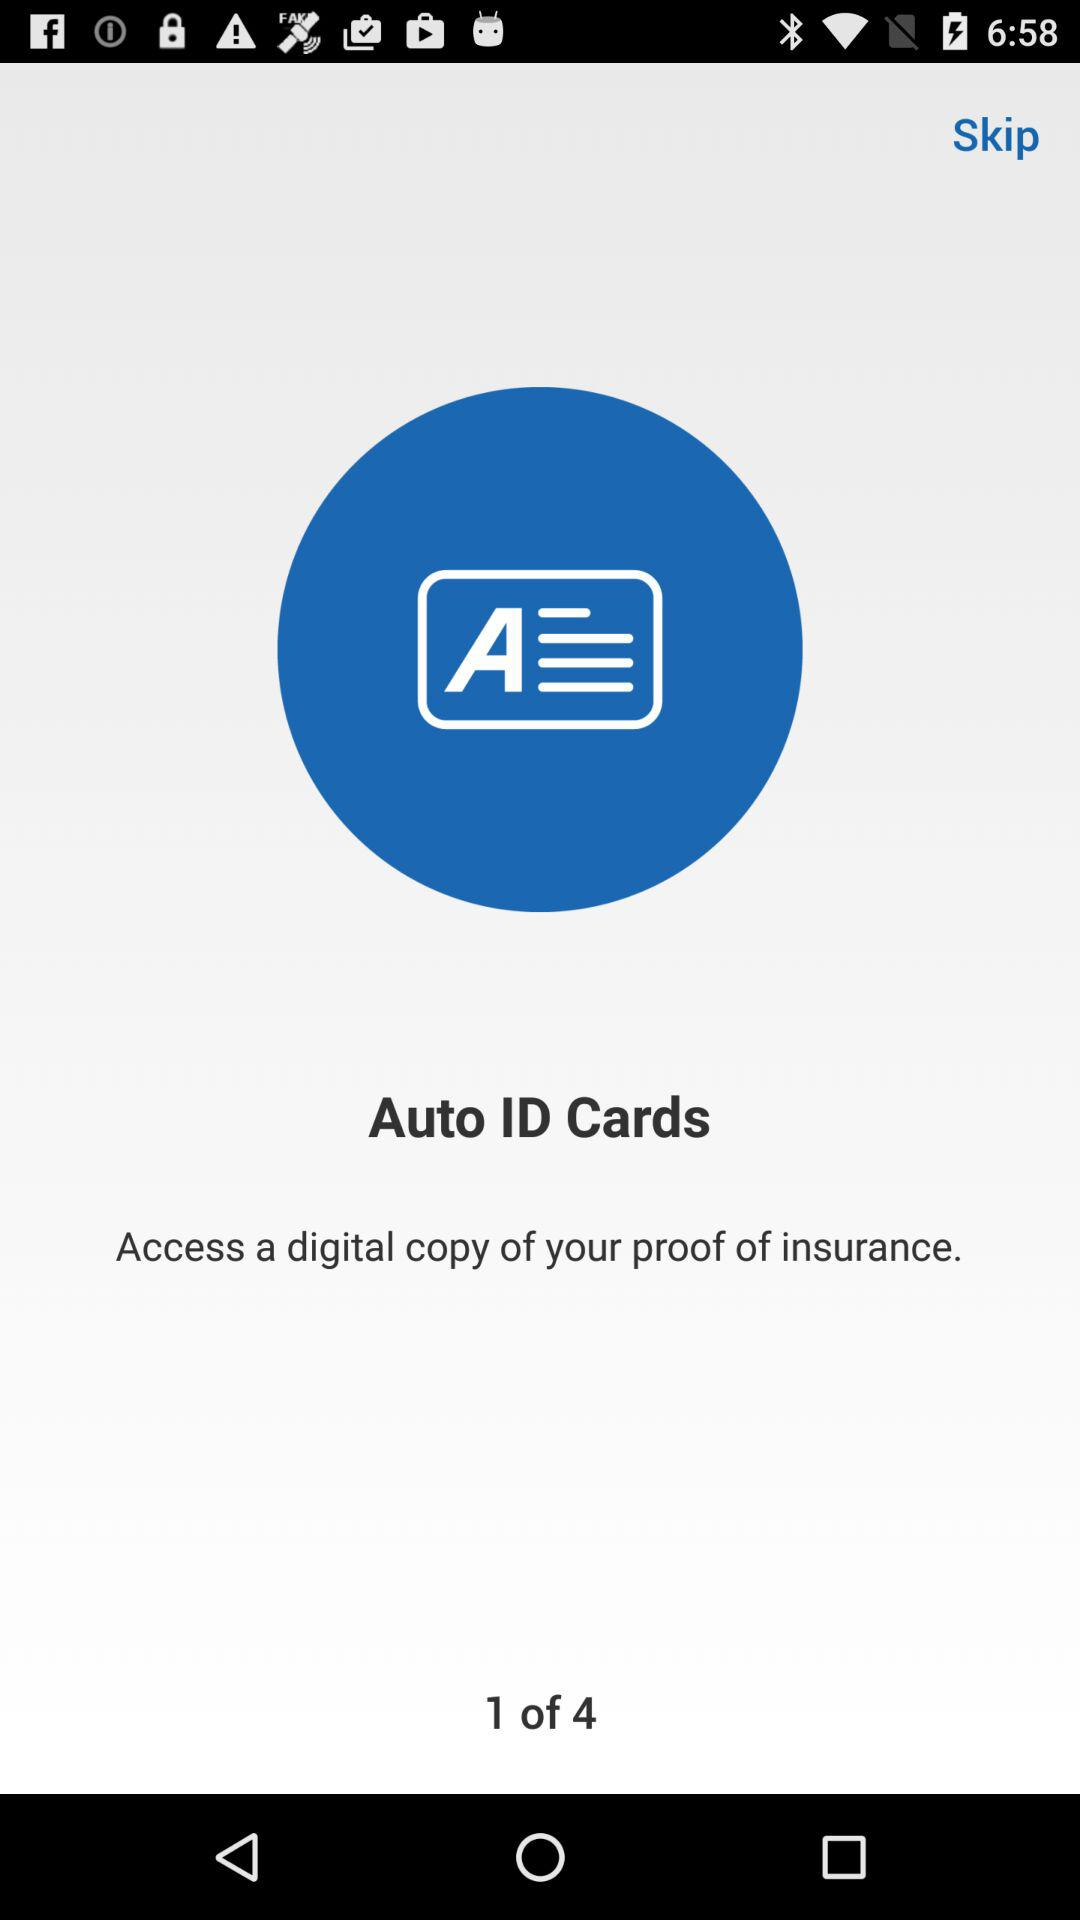Which page is the person on? The person is on the first page. 